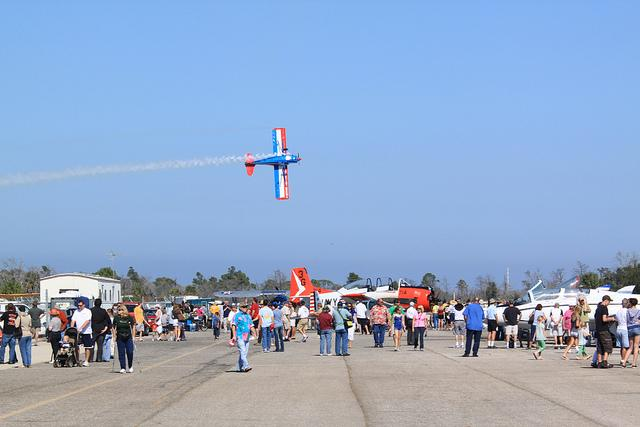Who will be riding those planes? Please explain your reasoning. stunt pilots. This is a stunt plane at an air show and is piloted by a stunt pilot. 